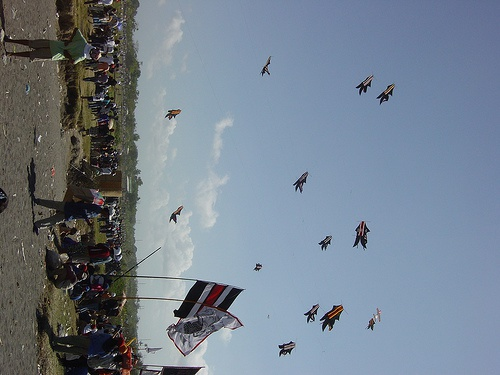Describe the objects in this image and their specific colors. I can see people in black, gray, darkgreen, and maroon tones, people in black, gray, darkgray, and darkgreen tones, people in black, gray, and darkgray tones, people in black, gray, and darkgreen tones, and people in black, gray, maroon, and darkgreen tones in this image. 